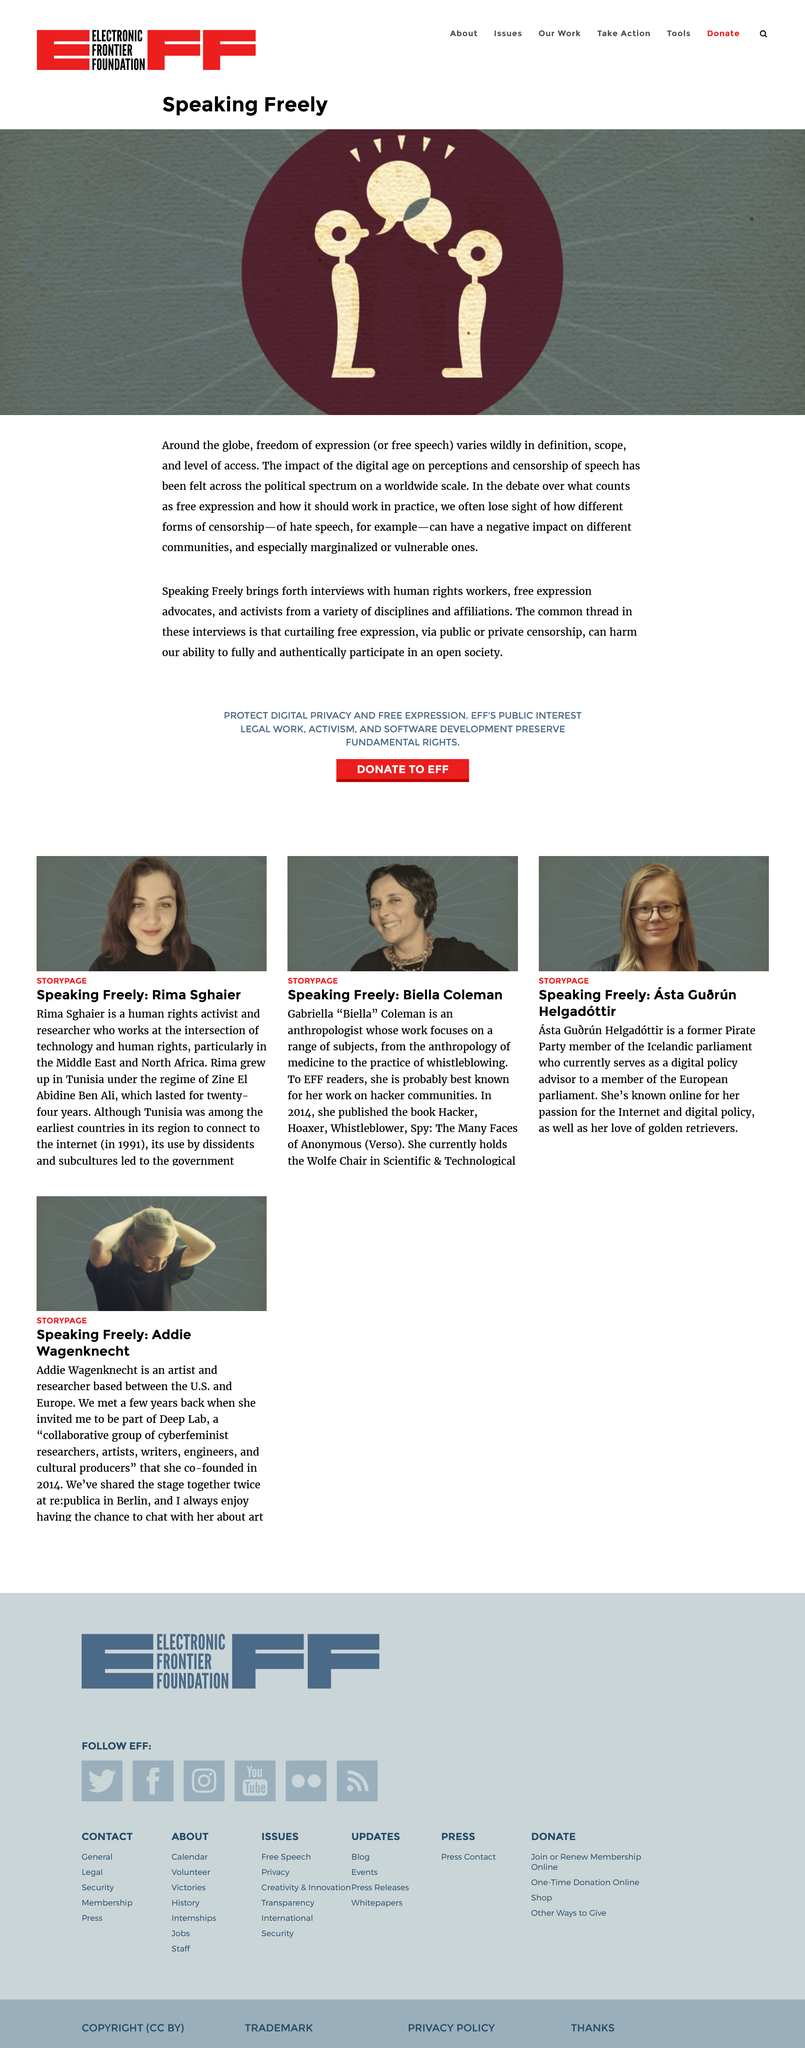Highlight a few significant elements in this photo. According to the article, the other term for Freedom of Expression is Free Speech. Speaking Freely interviews human rights workers, free expression advocates, and activists. Curtailing free expression, through public or private censorship, impairs our capacity to engage authentically in open and democratic societies. 